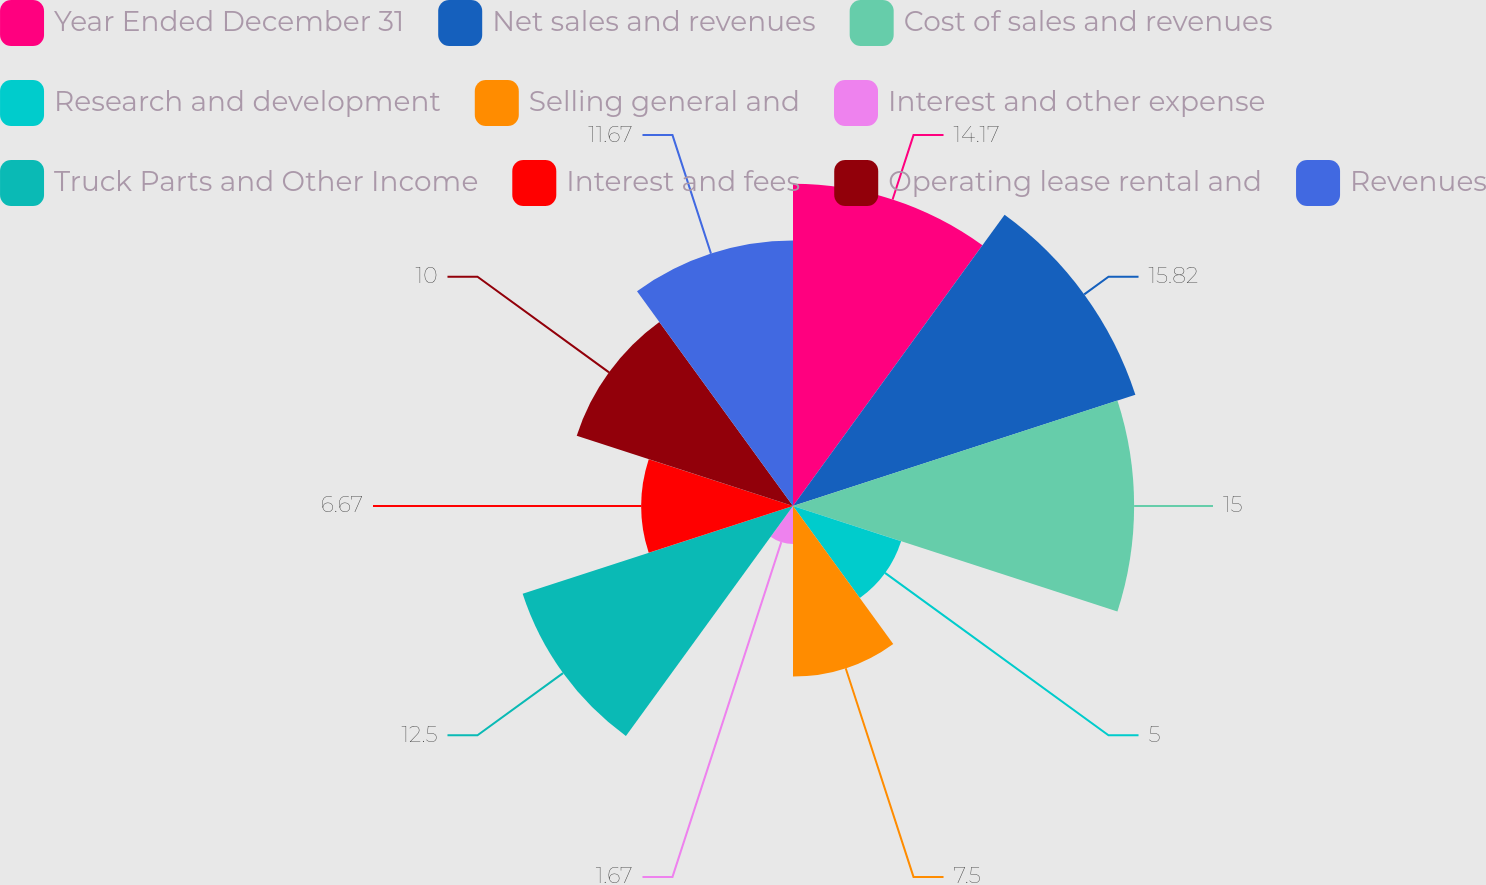Convert chart. <chart><loc_0><loc_0><loc_500><loc_500><pie_chart><fcel>Year Ended December 31<fcel>Net sales and revenues<fcel>Cost of sales and revenues<fcel>Research and development<fcel>Selling general and<fcel>Interest and other expense<fcel>Truck Parts and Other Income<fcel>Interest and fees<fcel>Operating lease rental and<fcel>Revenues<nl><fcel>14.17%<fcel>15.83%<fcel>15.0%<fcel>5.0%<fcel>7.5%<fcel>1.67%<fcel>12.5%<fcel>6.67%<fcel>10.0%<fcel>11.67%<nl></chart> 